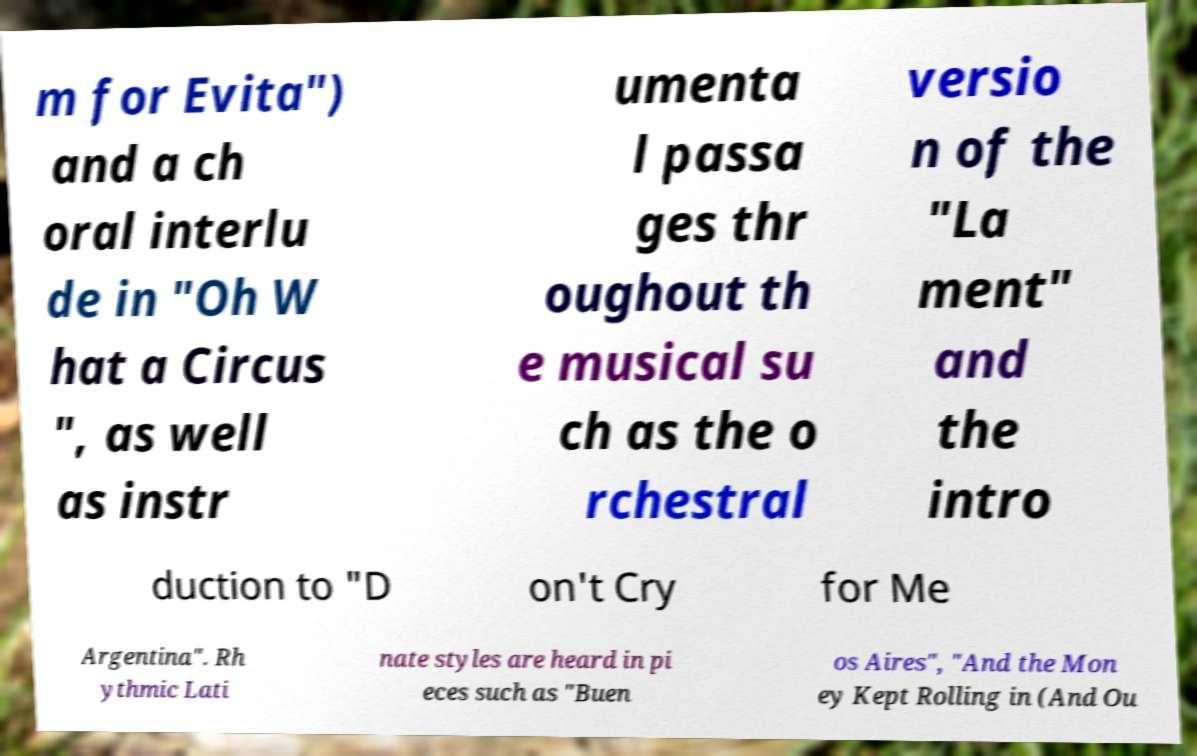Please read and relay the text visible in this image. What does it say? m for Evita") and a ch oral interlu de in "Oh W hat a Circus ", as well as instr umenta l passa ges thr oughout th e musical su ch as the o rchestral versio n of the "La ment" and the intro duction to "D on't Cry for Me Argentina". Rh ythmic Lati nate styles are heard in pi eces such as "Buen os Aires", "And the Mon ey Kept Rolling in (And Ou 